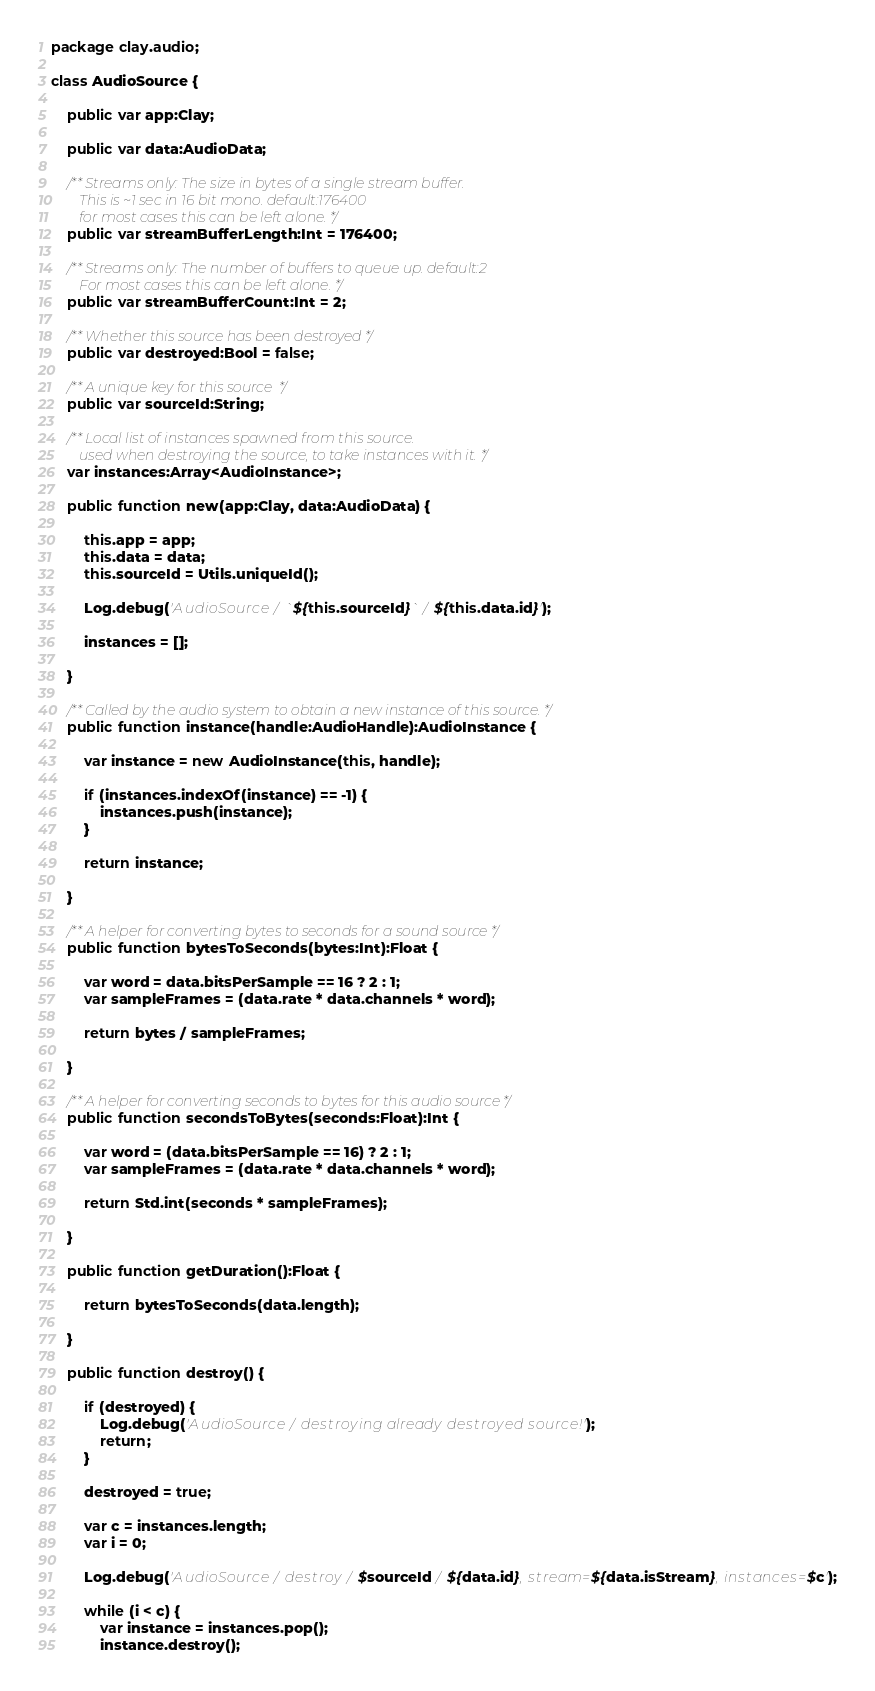Convert code to text. <code><loc_0><loc_0><loc_500><loc_500><_Haxe_>package clay.audio;

class AudioSource {

    public var app:Clay;

    public var data:AudioData;

    /** Streams only: The size in bytes of a single stream buffer.
        This is ~1 sec in 16 bit mono. default:176400
        for most cases this can be left alone. */
    public var streamBufferLength:Int = 176400;

    /** Streams only: The number of buffers to queue up. default:2
        For most cases this can be left alone. */
    public var streamBufferCount:Int = 2;

    /** Whether this source has been destroyed */
    public var destroyed:Bool = false;

    /** A unique key for this source  */
    public var sourceId:String;

    /** Local list of instances spawned from this source.
        used when destroying the source, to take instances with it. */
    var instances:Array<AudioInstance>;

    public function new(app:Clay, data:AudioData) {

        this.app = app;
        this.data = data;
        this.sourceId = Utils.uniqueId();

        Log.debug('AudioSource / `${this.sourceId}` / ${this.data.id}');

        instances = [];

    }

    /** Called by the audio system to obtain a new instance of this source. */
    public function instance(handle:AudioHandle):AudioInstance {

        var instance = new AudioInstance(this, handle);

        if (instances.indexOf(instance) == -1) {
            instances.push(instance);
        }

        return instance;

    }

    /** A helper for converting bytes to seconds for a sound source */
    public function bytesToSeconds(bytes:Int):Float {

        var word = data.bitsPerSample == 16 ? 2 : 1;
        var sampleFrames = (data.rate * data.channels * word);

        return bytes / sampleFrames;

    }

    /** A helper for converting seconds to bytes for this audio source */
    public function secondsToBytes(seconds:Float):Int {

        var word = (data.bitsPerSample == 16) ? 2 : 1;
        var sampleFrames = (data.rate * data.channels * word);

        return Std.int(seconds * sampleFrames);

    }

    public function getDuration():Float {

        return bytesToSeconds(data.length);

    }

    public function destroy() {

        if (destroyed) {
            Log.debug('AudioSource / destroying already destroyed source!');
            return;
        }

        destroyed = true;

        var c = instances.length;
        var i = 0;

        Log.debug('AudioSource / destroy / $sourceId / ${data.id}, stream=${data.isStream}, instances=$c');

        while (i < c) {
            var instance = instances.pop();
            instance.destroy();</code> 